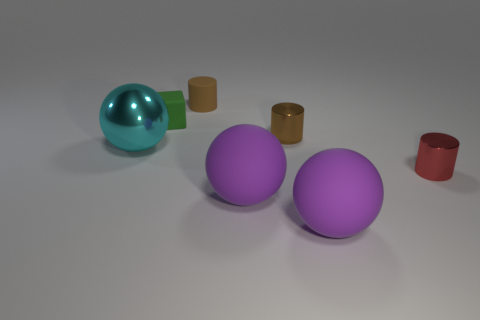Add 1 tiny balls. How many objects exist? 8 Subtract all cubes. How many objects are left? 6 Add 1 balls. How many balls are left? 4 Add 5 tiny purple metal cylinders. How many tiny purple metal cylinders exist? 5 Subtract 0 cyan cylinders. How many objects are left? 7 Subtract all small red shiny objects. Subtract all large purple matte objects. How many objects are left? 4 